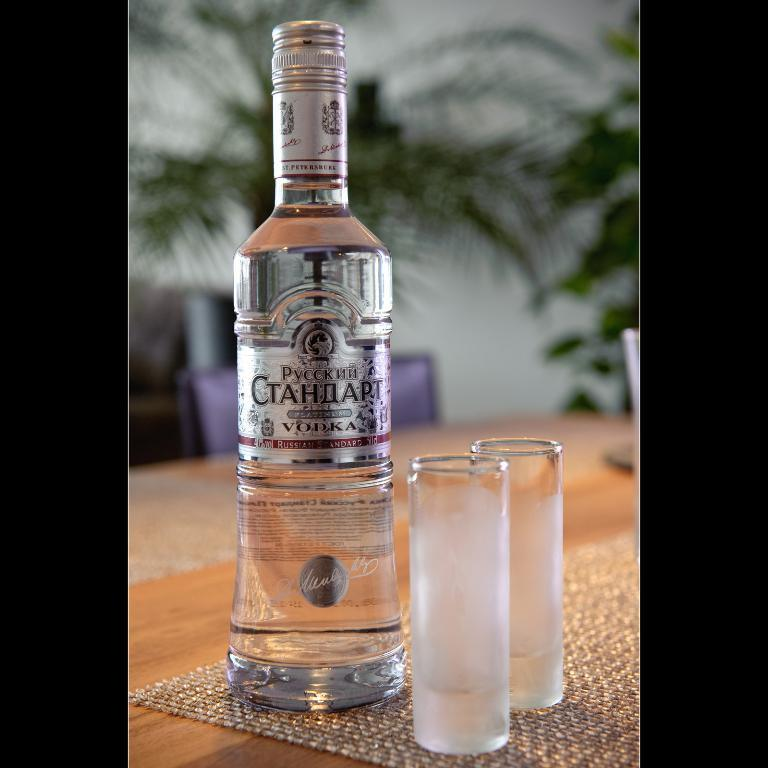What is located in the middle of the image? There is a bottle in the middle of the image. Where are the glasses placed in the image? The glasses are on a yellow table in the image. What type of vegetation can be seen in the background of the image? There are green plants in the background of the image. What type of lock is used to secure the quiver in the image? There is no lock or quiver present in the image. 